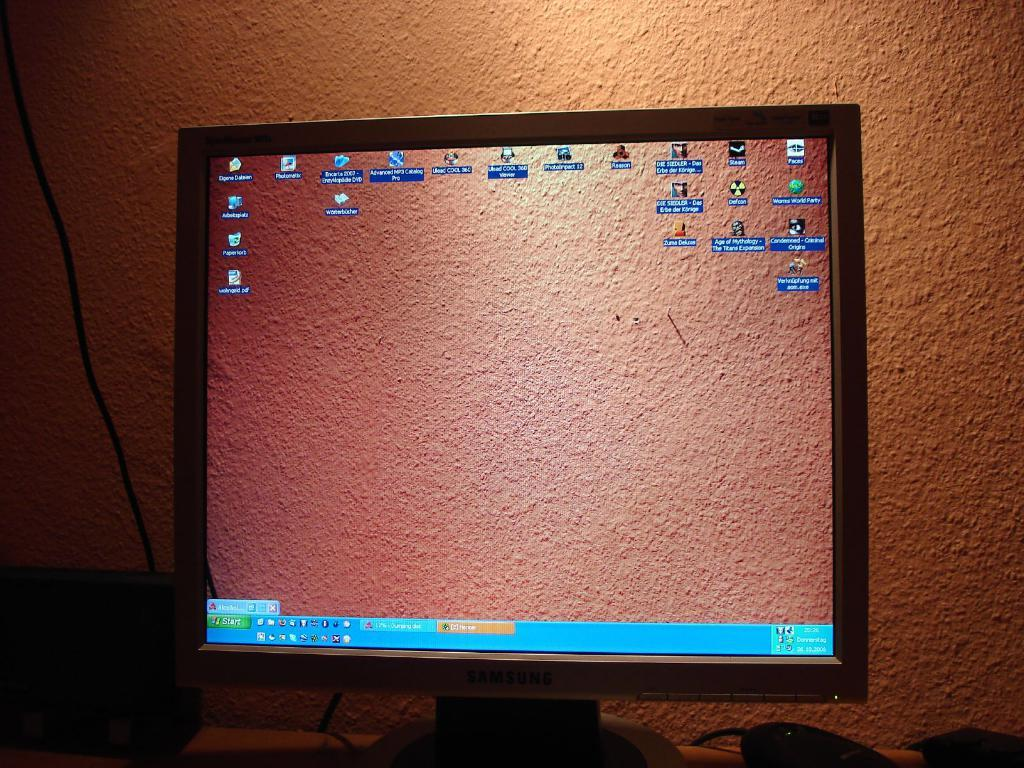Provide a one-sentence caption for the provided image. a screen shot of a computer monitor with Start Icons and windows Icons. 